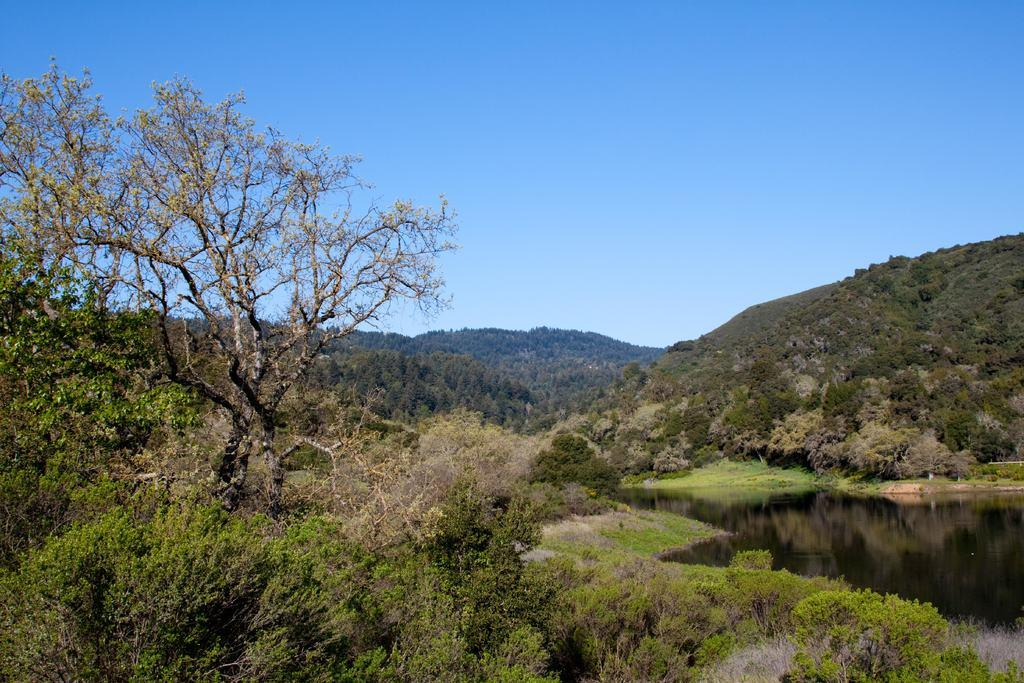What is the primary element visible in the image? There is water in the image. What type of natural features can be seen in the image? There are trees and mountains in the image. What is visible in the background of the image? The sky is visible in the background of the image. How does the goose contribute to the debt in the image? There is no goose or mention of debt in the image. 